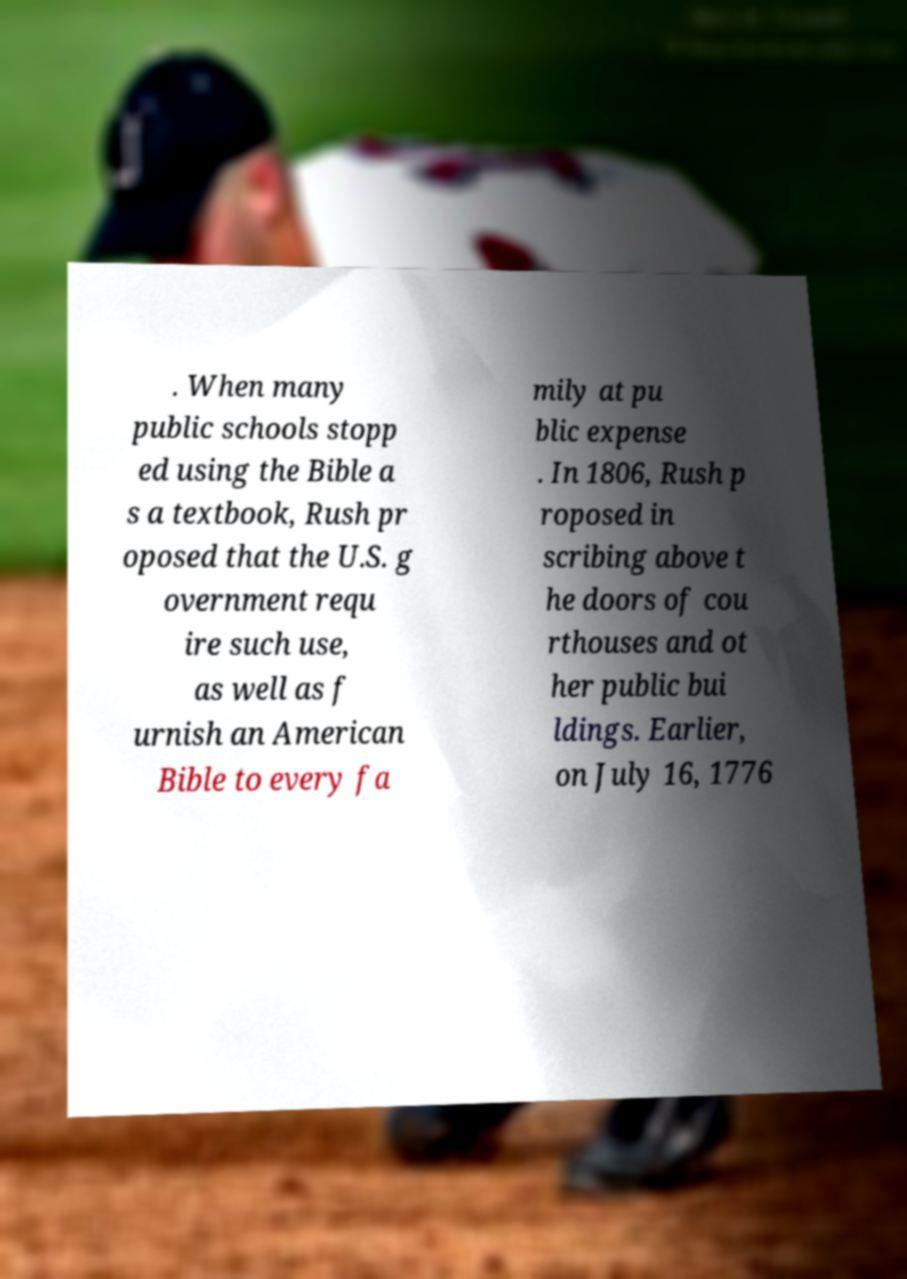For documentation purposes, I need the text within this image transcribed. Could you provide that? . When many public schools stopp ed using the Bible a s a textbook, Rush pr oposed that the U.S. g overnment requ ire such use, as well as f urnish an American Bible to every fa mily at pu blic expense . In 1806, Rush p roposed in scribing above t he doors of cou rthouses and ot her public bui ldings. Earlier, on July 16, 1776 